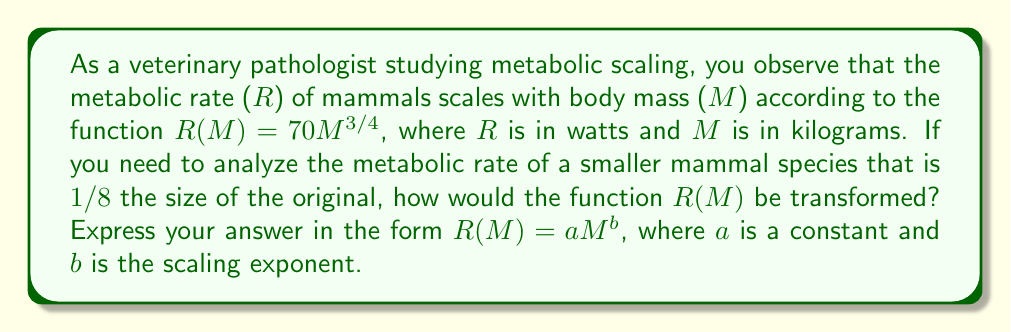Provide a solution to this math problem. To solve this problem, we need to consider how scaling affects the function $R(M) = 70M^{3/4}$.

1) First, let's consider the transformation of $M$. If we're looking at a mammal that is $1/8$ the size of the original, we can represent this as:

   $M_{new} = \frac{1}{8}M_{original}$

2) Now, we need to substitute this into our original function:

   $R(M_{new}) = 70(M_{new})^{3/4}$
   $R(\frac{1}{8}M) = 70(\frac{1}{8}M)^{3/4}$

3) Let's simplify the right side:

   $70(\frac{1}{8}M)^{3/4} = 70 \cdot \frac{1}{8^{3/4}} \cdot M^{3/4}$

4) Simplify $\frac{1}{8^{3/4}}$:

   $8^{3/4} = (2^3)^{3/4} = 2^{9/4} = 4\sqrt{2}$

   So, $\frac{1}{8^{3/4}} = \frac{1}{4\sqrt{2}} = \frac{\sqrt{2}}{8}$

5) Substituting this back:

   $R(\frac{1}{8}M) = 70 \cdot \frac{\sqrt{2}}{8} \cdot M^{3/4}$

6) Simplify:

   $R(\frac{1}{8}M) = \frac{70\sqrt{2}}{8} \cdot M^{3/4} \approx 24.75 \cdot M^{3/4}$

Therefore, the transformed function is $R(M) = 24.75M^{3/4}$.
Answer: $R(M) = 24.75M^{3/4}$ 